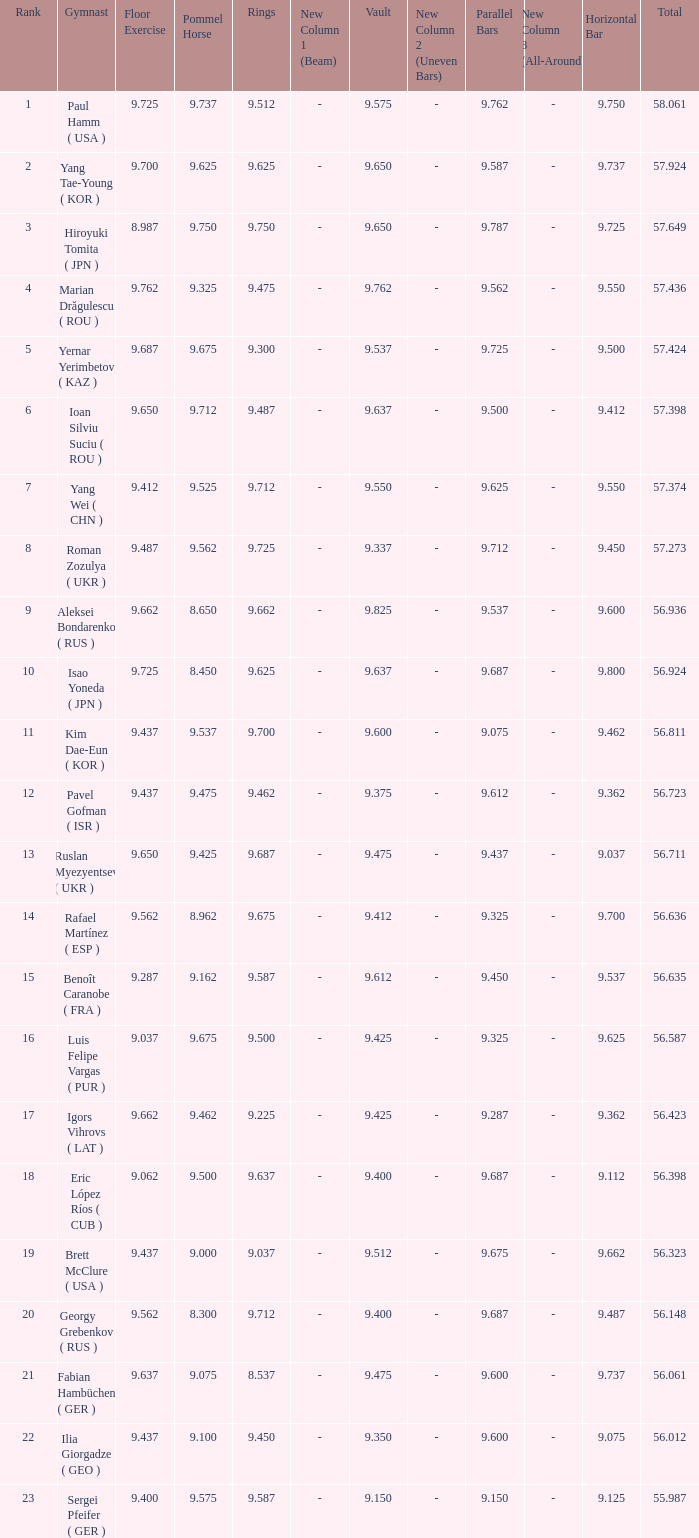What is the total score when the score for floor exercise was 9.287? 56.635. 